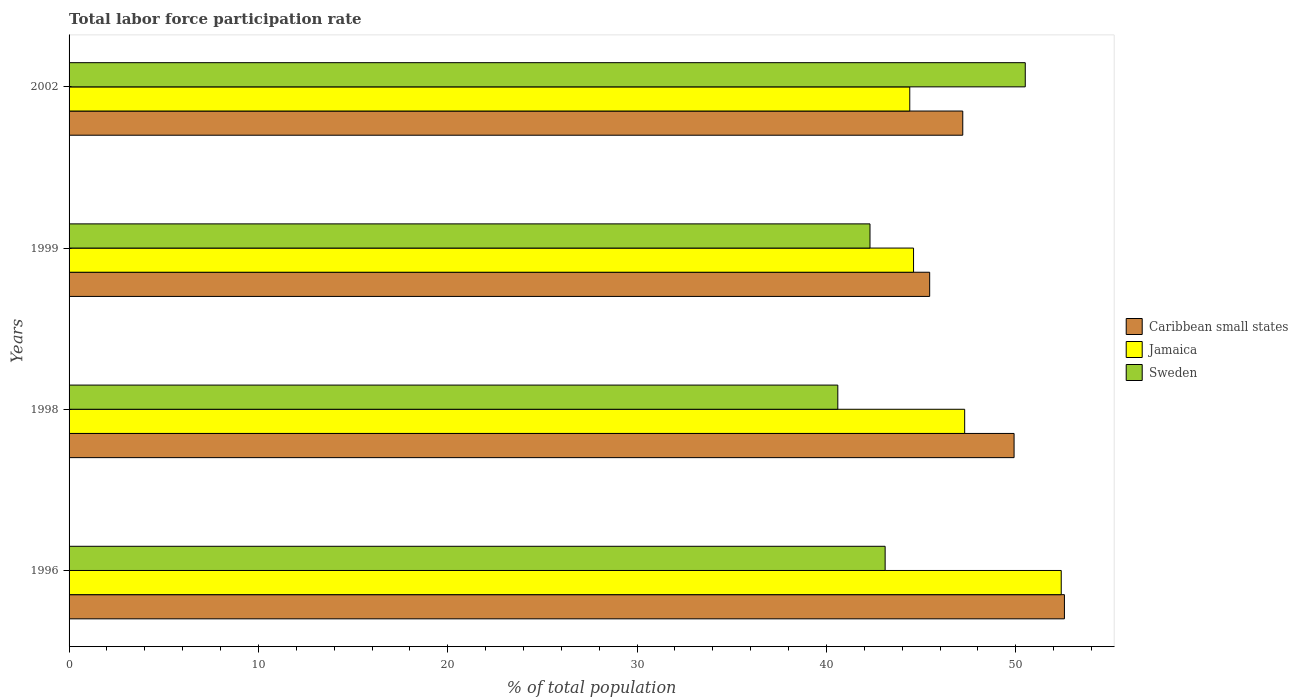How many groups of bars are there?
Provide a succinct answer. 4. Are the number of bars per tick equal to the number of legend labels?
Provide a succinct answer. Yes. Are the number of bars on each tick of the Y-axis equal?
Provide a short and direct response. Yes. What is the label of the 3rd group of bars from the top?
Your answer should be compact. 1998. In how many cases, is the number of bars for a given year not equal to the number of legend labels?
Provide a succinct answer. 0. What is the total labor force participation rate in Sweden in 1996?
Keep it short and to the point. 43.1. Across all years, what is the maximum total labor force participation rate in Jamaica?
Your response must be concise. 52.4. Across all years, what is the minimum total labor force participation rate in Sweden?
Keep it short and to the point. 40.6. In which year was the total labor force participation rate in Jamaica maximum?
Provide a succinct answer. 1996. In which year was the total labor force participation rate in Caribbean small states minimum?
Make the answer very short. 1999. What is the total total labor force participation rate in Jamaica in the graph?
Provide a short and direct response. 188.7. What is the difference between the total labor force participation rate in Sweden in 1998 and that in 1999?
Provide a short and direct response. -1.7. What is the difference between the total labor force participation rate in Sweden in 1996 and the total labor force participation rate in Jamaica in 2002?
Make the answer very short. -1.3. What is the average total labor force participation rate in Jamaica per year?
Your response must be concise. 47.18. In the year 1996, what is the difference between the total labor force participation rate in Caribbean small states and total labor force participation rate in Sweden?
Your answer should be compact. 9.47. What is the ratio of the total labor force participation rate in Caribbean small states in 1998 to that in 1999?
Keep it short and to the point. 1.1. Is the difference between the total labor force participation rate in Caribbean small states in 1996 and 2002 greater than the difference between the total labor force participation rate in Sweden in 1996 and 2002?
Your answer should be very brief. Yes. What is the difference between the highest and the second highest total labor force participation rate in Caribbean small states?
Your answer should be very brief. 2.66. What is the difference between the highest and the lowest total labor force participation rate in Caribbean small states?
Provide a short and direct response. 7.12. Is the sum of the total labor force participation rate in Jamaica in 1998 and 1999 greater than the maximum total labor force participation rate in Sweden across all years?
Give a very brief answer. Yes. What does the 1st bar from the top in 1999 represents?
Ensure brevity in your answer.  Sweden. What does the 1st bar from the bottom in 2002 represents?
Ensure brevity in your answer.  Caribbean small states. Is it the case that in every year, the sum of the total labor force participation rate in Caribbean small states and total labor force participation rate in Sweden is greater than the total labor force participation rate in Jamaica?
Provide a succinct answer. Yes. Are all the bars in the graph horizontal?
Provide a succinct answer. Yes. What is the difference between two consecutive major ticks on the X-axis?
Make the answer very short. 10. Are the values on the major ticks of X-axis written in scientific E-notation?
Your answer should be very brief. No. Does the graph contain any zero values?
Your answer should be very brief. No. Does the graph contain grids?
Provide a succinct answer. No. Where does the legend appear in the graph?
Your response must be concise. Center right. How many legend labels are there?
Your answer should be compact. 3. What is the title of the graph?
Your answer should be compact. Total labor force participation rate. What is the label or title of the X-axis?
Keep it short and to the point. % of total population. What is the % of total population of Caribbean small states in 1996?
Provide a succinct answer. 52.57. What is the % of total population in Jamaica in 1996?
Your answer should be compact. 52.4. What is the % of total population in Sweden in 1996?
Provide a succinct answer. 43.1. What is the % of total population of Caribbean small states in 1998?
Offer a terse response. 49.91. What is the % of total population of Jamaica in 1998?
Give a very brief answer. 47.3. What is the % of total population in Sweden in 1998?
Make the answer very short. 40.6. What is the % of total population of Caribbean small states in 1999?
Provide a succinct answer. 45.45. What is the % of total population of Jamaica in 1999?
Offer a very short reply. 44.6. What is the % of total population of Sweden in 1999?
Your answer should be very brief. 42.3. What is the % of total population of Caribbean small states in 2002?
Provide a short and direct response. 47.2. What is the % of total population in Jamaica in 2002?
Offer a very short reply. 44.4. What is the % of total population in Sweden in 2002?
Offer a terse response. 50.5. Across all years, what is the maximum % of total population in Caribbean small states?
Make the answer very short. 52.57. Across all years, what is the maximum % of total population in Jamaica?
Your response must be concise. 52.4. Across all years, what is the maximum % of total population in Sweden?
Provide a succinct answer. 50.5. Across all years, what is the minimum % of total population in Caribbean small states?
Ensure brevity in your answer.  45.45. Across all years, what is the minimum % of total population in Jamaica?
Your answer should be compact. 44.4. Across all years, what is the minimum % of total population of Sweden?
Provide a succinct answer. 40.6. What is the total % of total population of Caribbean small states in the graph?
Provide a short and direct response. 195.13. What is the total % of total population of Jamaica in the graph?
Make the answer very short. 188.7. What is the total % of total population of Sweden in the graph?
Make the answer very short. 176.5. What is the difference between the % of total population in Caribbean small states in 1996 and that in 1998?
Provide a short and direct response. 2.66. What is the difference between the % of total population in Sweden in 1996 and that in 1998?
Make the answer very short. 2.5. What is the difference between the % of total population of Caribbean small states in 1996 and that in 1999?
Your answer should be compact. 7.12. What is the difference between the % of total population in Jamaica in 1996 and that in 1999?
Your answer should be compact. 7.8. What is the difference between the % of total population in Sweden in 1996 and that in 1999?
Keep it short and to the point. 0.8. What is the difference between the % of total population of Caribbean small states in 1996 and that in 2002?
Make the answer very short. 5.37. What is the difference between the % of total population of Jamaica in 1996 and that in 2002?
Provide a short and direct response. 8. What is the difference between the % of total population of Sweden in 1996 and that in 2002?
Provide a succinct answer. -7.4. What is the difference between the % of total population in Caribbean small states in 1998 and that in 1999?
Your answer should be very brief. 4.46. What is the difference between the % of total population in Jamaica in 1998 and that in 1999?
Make the answer very short. 2.7. What is the difference between the % of total population of Caribbean small states in 1998 and that in 2002?
Ensure brevity in your answer.  2.71. What is the difference between the % of total population in Jamaica in 1998 and that in 2002?
Keep it short and to the point. 2.9. What is the difference between the % of total population of Sweden in 1998 and that in 2002?
Make the answer very short. -9.9. What is the difference between the % of total population in Caribbean small states in 1999 and that in 2002?
Keep it short and to the point. -1.75. What is the difference between the % of total population of Jamaica in 1999 and that in 2002?
Give a very brief answer. 0.2. What is the difference between the % of total population of Sweden in 1999 and that in 2002?
Make the answer very short. -8.2. What is the difference between the % of total population in Caribbean small states in 1996 and the % of total population in Jamaica in 1998?
Offer a terse response. 5.27. What is the difference between the % of total population in Caribbean small states in 1996 and the % of total population in Sweden in 1998?
Keep it short and to the point. 11.97. What is the difference between the % of total population in Jamaica in 1996 and the % of total population in Sweden in 1998?
Give a very brief answer. 11.8. What is the difference between the % of total population of Caribbean small states in 1996 and the % of total population of Jamaica in 1999?
Provide a short and direct response. 7.97. What is the difference between the % of total population of Caribbean small states in 1996 and the % of total population of Sweden in 1999?
Your answer should be very brief. 10.27. What is the difference between the % of total population of Caribbean small states in 1996 and the % of total population of Jamaica in 2002?
Give a very brief answer. 8.17. What is the difference between the % of total population in Caribbean small states in 1996 and the % of total population in Sweden in 2002?
Keep it short and to the point. 2.07. What is the difference between the % of total population of Caribbean small states in 1998 and the % of total population of Jamaica in 1999?
Ensure brevity in your answer.  5.31. What is the difference between the % of total population of Caribbean small states in 1998 and the % of total population of Sweden in 1999?
Provide a succinct answer. 7.61. What is the difference between the % of total population in Jamaica in 1998 and the % of total population in Sweden in 1999?
Your response must be concise. 5. What is the difference between the % of total population in Caribbean small states in 1998 and the % of total population in Jamaica in 2002?
Give a very brief answer. 5.51. What is the difference between the % of total population in Caribbean small states in 1998 and the % of total population in Sweden in 2002?
Offer a terse response. -0.59. What is the difference between the % of total population in Jamaica in 1998 and the % of total population in Sweden in 2002?
Offer a very short reply. -3.2. What is the difference between the % of total population of Caribbean small states in 1999 and the % of total population of Jamaica in 2002?
Give a very brief answer. 1.05. What is the difference between the % of total population in Caribbean small states in 1999 and the % of total population in Sweden in 2002?
Offer a terse response. -5.05. What is the average % of total population in Caribbean small states per year?
Ensure brevity in your answer.  48.78. What is the average % of total population of Jamaica per year?
Offer a very short reply. 47.17. What is the average % of total population of Sweden per year?
Offer a very short reply. 44.12. In the year 1996, what is the difference between the % of total population of Caribbean small states and % of total population of Jamaica?
Provide a short and direct response. 0.17. In the year 1996, what is the difference between the % of total population of Caribbean small states and % of total population of Sweden?
Offer a very short reply. 9.47. In the year 1996, what is the difference between the % of total population in Jamaica and % of total population in Sweden?
Your response must be concise. 9.3. In the year 1998, what is the difference between the % of total population in Caribbean small states and % of total population in Jamaica?
Ensure brevity in your answer.  2.61. In the year 1998, what is the difference between the % of total population in Caribbean small states and % of total population in Sweden?
Keep it short and to the point. 9.31. In the year 1998, what is the difference between the % of total population in Jamaica and % of total population in Sweden?
Keep it short and to the point. 6.7. In the year 1999, what is the difference between the % of total population of Caribbean small states and % of total population of Jamaica?
Your response must be concise. 0.85. In the year 1999, what is the difference between the % of total population of Caribbean small states and % of total population of Sweden?
Provide a short and direct response. 3.15. In the year 2002, what is the difference between the % of total population in Caribbean small states and % of total population in Jamaica?
Give a very brief answer. 2.8. In the year 2002, what is the difference between the % of total population of Caribbean small states and % of total population of Sweden?
Offer a terse response. -3.3. In the year 2002, what is the difference between the % of total population in Jamaica and % of total population in Sweden?
Keep it short and to the point. -6.1. What is the ratio of the % of total population in Caribbean small states in 1996 to that in 1998?
Give a very brief answer. 1.05. What is the ratio of the % of total population in Jamaica in 1996 to that in 1998?
Your response must be concise. 1.11. What is the ratio of the % of total population of Sweden in 1996 to that in 1998?
Offer a very short reply. 1.06. What is the ratio of the % of total population in Caribbean small states in 1996 to that in 1999?
Make the answer very short. 1.16. What is the ratio of the % of total population in Jamaica in 1996 to that in 1999?
Offer a very short reply. 1.17. What is the ratio of the % of total population of Sweden in 1996 to that in 1999?
Offer a very short reply. 1.02. What is the ratio of the % of total population in Caribbean small states in 1996 to that in 2002?
Offer a terse response. 1.11. What is the ratio of the % of total population in Jamaica in 1996 to that in 2002?
Offer a terse response. 1.18. What is the ratio of the % of total population of Sweden in 1996 to that in 2002?
Provide a succinct answer. 0.85. What is the ratio of the % of total population of Caribbean small states in 1998 to that in 1999?
Your answer should be very brief. 1.1. What is the ratio of the % of total population in Jamaica in 1998 to that in 1999?
Give a very brief answer. 1.06. What is the ratio of the % of total population of Sweden in 1998 to that in 1999?
Provide a short and direct response. 0.96. What is the ratio of the % of total population in Caribbean small states in 1998 to that in 2002?
Provide a short and direct response. 1.06. What is the ratio of the % of total population in Jamaica in 1998 to that in 2002?
Offer a very short reply. 1.07. What is the ratio of the % of total population of Sweden in 1998 to that in 2002?
Provide a short and direct response. 0.8. What is the ratio of the % of total population in Caribbean small states in 1999 to that in 2002?
Provide a short and direct response. 0.96. What is the ratio of the % of total population of Jamaica in 1999 to that in 2002?
Ensure brevity in your answer.  1. What is the ratio of the % of total population of Sweden in 1999 to that in 2002?
Offer a very short reply. 0.84. What is the difference between the highest and the second highest % of total population of Caribbean small states?
Ensure brevity in your answer.  2.66. What is the difference between the highest and the second highest % of total population in Jamaica?
Your answer should be compact. 5.1. What is the difference between the highest and the lowest % of total population of Caribbean small states?
Your answer should be compact. 7.12. 